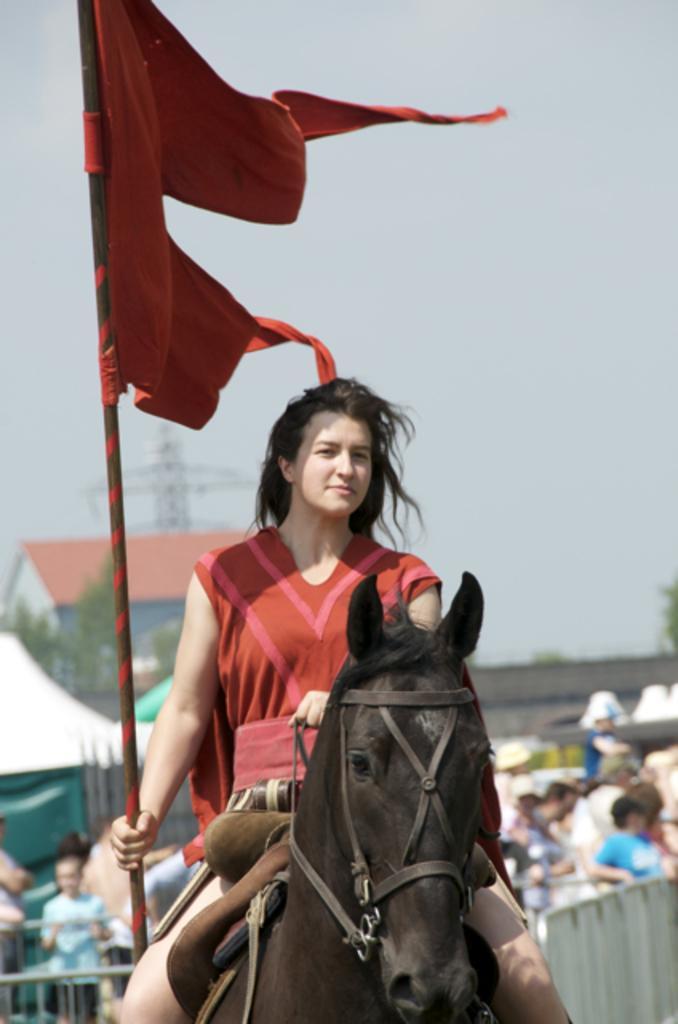Can you describe this image briefly? In this image I see a woman who is sitting on a horse and she is holding a flag in her hand and I can also see this woman is wearing a red dress. In the background I see number of people, buildings, trees and the sky. 